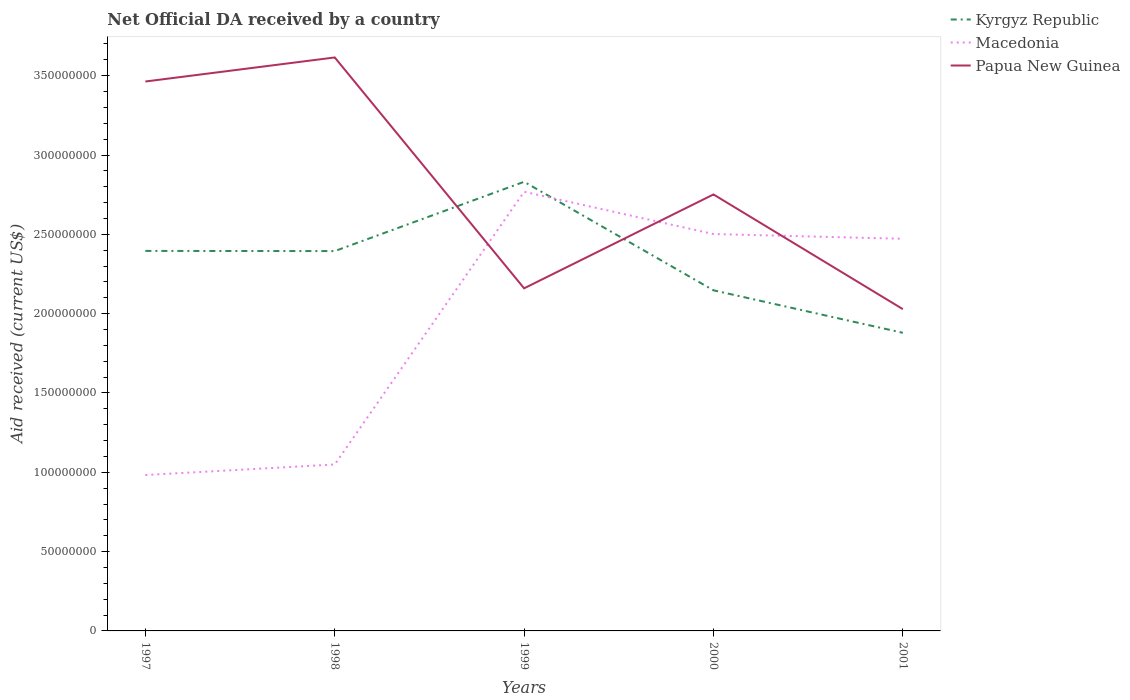How many different coloured lines are there?
Offer a very short reply. 3. Does the line corresponding to Papua New Guinea intersect with the line corresponding to Kyrgyz Republic?
Provide a succinct answer. Yes. Across all years, what is the maximum net official development assistance aid received in Kyrgyz Republic?
Offer a terse response. 1.88e+08. In which year was the net official development assistance aid received in Papua New Guinea maximum?
Make the answer very short. 2001. What is the total net official development assistance aid received in Kyrgyz Republic in the graph?
Give a very brief answer. 6.84e+07. What is the difference between the highest and the second highest net official development assistance aid received in Papua New Guinea?
Ensure brevity in your answer.  1.59e+08. Is the net official development assistance aid received in Papua New Guinea strictly greater than the net official development assistance aid received in Kyrgyz Republic over the years?
Make the answer very short. No. How many lines are there?
Ensure brevity in your answer.  3. How are the legend labels stacked?
Your response must be concise. Vertical. What is the title of the graph?
Your response must be concise. Net Official DA received by a country. Does "Portugal" appear as one of the legend labels in the graph?
Your answer should be very brief. No. What is the label or title of the X-axis?
Offer a terse response. Years. What is the label or title of the Y-axis?
Ensure brevity in your answer.  Aid received (current US$). What is the Aid received (current US$) of Kyrgyz Republic in 1997?
Give a very brief answer. 2.40e+08. What is the Aid received (current US$) of Macedonia in 1997?
Keep it short and to the point. 9.83e+07. What is the Aid received (current US$) in Papua New Guinea in 1997?
Keep it short and to the point. 3.46e+08. What is the Aid received (current US$) in Kyrgyz Republic in 1998?
Give a very brief answer. 2.39e+08. What is the Aid received (current US$) of Macedonia in 1998?
Provide a short and direct response. 1.05e+08. What is the Aid received (current US$) of Papua New Guinea in 1998?
Offer a very short reply. 3.62e+08. What is the Aid received (current US$) of Kyrgyz Republic in 1999?
Make the answer very short. 2.83e+08. What is the Aid received (current US$) of Macedonia in 1999?
Provide a short and direct response. 2.77e+08. What is the Aid received (current US$) of Papua New Guinea in 1999?
Offer a very short reply. 2.16e+08. What is the Aid received (current US$) in Kyrgyz Republic in 2000?
Offer a terse response. 2.15e+08. What is the Aid received (current US$) of Macedonia in 2000?
Offer a very short reply. 2.50e+08. What is the Aid received (current US$) in Papua New Guinea in 2000?
Your answer should be very brief. 2.75e+08. What is the Aid received (current US$) in Kyrgyz Republic in 2001?
Provide a short and direct response. 1.88e+08. What is the Aid received (current US$) in Macedonia in 2001?
Provide a succinct answer. 2.47e+08. What is the Aid received (current US$) in Papua New Guinea in 2001?
Offer a terse response. 2.03e+08. Across all years, what is the maximum Aid received (current US$) of Kyrgyz Republic?
Your response must be concise. 2.83e+08. Across all years, what is the maximum Aid received (current US$) in Macedonia?
Your answer should be very brief. 2.77e+08. Across all years, what is the maximum Aid received (current US$) of Papua New Guinea?
Offer a very short reply. 3.62e+08. Across all years, what is the minimum Aid received (current US$) in Kyrgyz Republic?
Ensure brevity in your answer.  1.88e+08. Across all years, what is the minimum Aid received (current US$) of Macedonia?
Offer a very short reply. 9.83e+07. Across all years, what is the minimum Aid received (current US$) of Papua New Guinea?
Give a very brief answer. 2.03e+08. What is the total Aid received (current US$) of Kyrgyz Republic in the graph?
Offer a terse response. 1.16e+09. What is the total Aid received (current US$) of Macedonia in the graph?
Give a very brief answer. 9.77e+08. What is the total Aid received (current US$) of Papua New Guinea in the graph?
Your response must be concise. 1.40e+09. What is the difference between the Aid received (current US$) in Kyrgyz Republic in 1997 and that in 1998?
Your answer should be very brief. 1.00e+05. What is the difference between the Aid received (current US$) in Macedonia in 1997 and that in 1998?
Your answer should be compact. -6.63e+06. What is the difference between the Aid received (current US$) of Papua New Guinea in 1997 and that in 1998?
Ensure brevity in your answer.  -1.52e+07. What is the difference between the Aid received (current US$) in Kyrgyz Republic in 1997 and that in 1999?
Give a very brief answer. -4.36e+07. What is the difference between the Aid received (current US$) in Macedonia in 1997 and that in 1999?
Your answer should be very brief. -1.79e+08. What is the difference between the Aid received (current US$) in Papua New Guinea in 1997 and that in 1999?
Keep it short and to the point. 1.30e+08. What is the difference between the Aid received (current US$) in Kyrgyz Republic in 1997 and that in 2000?
Your answer should be compact. 2.48e+07. What is the difference between the Aid received (current US$) of Macedonia in 1997 and that in 2000?
Your answer should be very brief. -1.52e+08. What is the difference between the Aid received (current US$) in Papua New Guinea in 1997 and that in 2000?
Your response must be concise. 7.12e+07. What is the difference between the Aid received (current US$) of Kyrgyz Republic in 1997 and that in 2001?
Offer a very short reply. 5.16e+07. What is the difference between the Aid received (current US$) of Macedonia in 1997 and that in 2001?
Your response must be concise. -1.49e+08. What is the difference between the Aid received (current US$) of Papua New Guinea in 1997 and that in 2001?
Your answer should be very brief. 1.44e+08. What is the difference between the Aid received (current US$) of Kyrgyz Republic in 1998 and that in 1999?
Your response must be concise. -4.37e+07. What is the difference between the Aid received (current US$) in Macedonia in 1998 and that in 1999?
Make the answer very short. -1.72e+08. What is the difference between the Aid received (current US$) in Papua New Guinea in 1998 and that in 1999?
Make the answer very short. 1.46e+08. What is the difference between the Aid received (current US$) of Kyrgyz Republic in 1998 and that in 2000?
Your response must be concise. 2.47e+07. What is the difference between the Aid received (current US$) of Macedonia in 1998 and that in 2000?
Provide a short and direct response. -1.45e+08. What is the difference between the Aid received (current US$) in Papua New Guinea in 1998 and that in 2000?
Your response must be concise. 8.64e+07. What is the difference between the Aid received (current US$) in Kyrgyz Republic in 1998 and that in 2001?
Offer a very short reply. 5.15e+07. What is the difference between the Aid received (current US$) in Macedonia in 1998 and that in 2001?
Provide a succinct answer. -1.42e+08. What is the difference between the Aid received (current US$) in Papua New Guinea in 1998 and that in 2001?
Offer a very short reply. 1.59e+08. What is the difference between the Aid received (current US$) in Kyrgyz Republic in 1999 and that in 2000?
Offer a very short reply. 6.84e+07. What is the difference between the Aid received (current US$) in Macedonia in 1999 and that in 2000?
Offer a very short reply. 2.66e+07. What is the difference between the Aid received (current US$) of Papua New Guinea in 1999 and that in 2000?
Provide a succinct answer. -5.92e+07. What is the difference between the Aid received (current US$) in Kyrgyz Republic in 1999 and that in 2001?
Your answer should be compact. 9.52e+07. What is the difference between the Aid received (current US$) in Macedonia in 1999 and that in 2001?
Provide a succinct answer. 2.96e+07. What is the difference between the Aid received (current US$) of Papua New Guinea in 1999 and that in 2001?
Your answer should be very brief. 1.31e+07. What is the difference between the Aid received (current US$) of Kyrgyz Republic in 2000 and that in 2001?
Offer a very short reply. 2.68e+07. What is the difference between the Aid received (current US$) of Macedonia in 2000 and that in 2001?
Give a very brief answer. 2.99e+06. What is the difference between the Aid received (current US$) of Papua New Guinea in 2000 and that in 2001?
Offer a very short reply. 7.23e+07. What is the difference between the Aid received (current US$) of Kyrgyz Republic in 1997 and the Aid received (current US$) of Macedonia in 1998?
Your response must be concise. 1.35e+08. What is the difference between the Aid received (current US$) of Kyrgyz Republic in 1997 and the Aid received (current US$) of Papua New Guinea in 1998?
Make the answer very short. -1.22e+08. What is the difference between the Aid received (current US$) in Macedonia in 1997 and the Aid received (current US$) in Papua New Guinea in 1998?
Your response must be concise. -2.63e+08. What is the difference between the Aid received (current US$) of Kyrgyz Republic in 1997 and the Aid received (current US$) of Macedonia in 1999?
Give a very brief answer. -3.73e+07. What is the difference between the Aid received (current US$) in Kyrgyz Republic in 1997 and the Aid received (current US$) in Papua New Guinea in 1999?
Give a very brief answer. 2.36e+07. What is the difference between the Aid received (current US$) of Macedonia in 1997 and the Aid received (current US$) of Papua New Guinea in 1999?
Offer a terse response. -1.18e+08. What is the difference between the Aid received (current US$) in Kyrgyz Republic in 1997 and the Aid received (current US$) in Macedonia in 2000?
Offer a terse response. -1.06e+07. What is the difference between the Aid received (current US$) in Kyrgyz Republic in 1997 and the Aid received (current US$) in Papua New Guinea in 2000?
Provide a succinct answer. -3.56e+07. What is the difference between the Aid received (current US$) of Macedonia in 1997 and the Aid received (current US$) of Papua New Guinea in 2000?
Give a very brief answer. -1.77e+08. What is the difference between the Aid received (current US$) of Kyrgyz Republic in 1997 and the Aid received (current US$) of Macedonia in 2001?
Ensure brevity in your answer.  -7.65e+06. What is the difference between the Aid received (current US$) of Kyrgyz Republic in 1997 and the Aid received (current US$) of Papua New Guinea in 2001?
Offer a very short reply. 3.67e+07. What is the difference between the Aid received (current US$) of Macedonia in 1997 and the Aid received (current US$) of Papua New Guinea in 2001?
Ensure brevity in your answer.  -1.05e+08. What is the difference between the Aid received (current US$) in Kyrgyz Republic in 1998 and the Aid received (current US$) in Macedonia in 1999?
Your answer should be compact. -3.74e+07. What is the difference between the Aid received (current US$) of Kyrgyz Republic in 1998 and the Aid received (current US$) of Papua New Guinea in 1999?
Provide a succinct answer. 2.35e+07. What is the difference between the Aid received (current US$) of Macedonia in 1998 and the Aid received (current US$) of Papua New Guinea in 1999?
Provide a short and direct response. -1.11e+08. What is the difference between the Aid received (current US$) in Kyrgyz Republic in 1998 and the Aid received (current US$) in Macedonia in 2000?
Give a very brief answer. -1.07e+07. What is the difference between the Aid received (current US$) in Kyrgyz Republic in 1998 and the Aid received (current US$) in Papua New Guinea in 2000?
Provide a short and direct response. -3.57e+07. What is the difference between the Aid received (current US$) in Macedonia in 1998 and the Aid received (current US$) in Papua New Guinea in 2000?
Ensure brevity in your answer.  -1.70e+08. What is the difference between the Aid received (current US$) in Kyrgyz Republic in 1998 and the Aid received (current US$) in Macedonia in 2001?
Provide a succinct answer. -7.75e+06. What is the difference between the Aid received (current US$) in Kyrgyz Republic in 1998 and the Aid received (current US$) in Papua New Guinea in 2001?
Offer a very short reply. 3.66e+07. What is the difference between the Aid received (current US$) in Macedonia in 1998 and the Aid received (current US$) in Papua New Guinea in 2001?
Your answer should be very brief. -9.79e+07. What is the difference between the Aid received (current US$) in Kyrgyz Republic in 1999 and the Aid received (current US$) in Macedonia in 2000?
Provide a short and direct response. 3.29e+07. What is the difference between the Aid received (current US$) of Kyrgyz Republic in 1999 and the Aid received (current US$) of Papua New Guinea in 2000?
Provide a short and direct response. 7.98e+06. What is the difference between the Aid received (current US$) in Macedonia in 1999 and the Aid received (current US$) in Papua New Guinea in 2000?
Offer a terse response. 1.68e+06. What is the difference between the Aid received (current US$) of Kyrgyz Republic in 1999 and the Aid received (current US$) of Macedonia in 2001?
Make the answer very short. 3.59e+07. What is the difference between the Aid received (current US$) of Kyrgyz Republic in 1999 and the Aid received (current US$) of Papua New Guinea in 2001?
Your answer should be very brief. 8.03e+07. What is the difference between the Aid received (current US$) of Macedonia in 1999 and the Aid received (current US$) of Papua New Guinea in 2001?
Keep it short and to the point. 7.40e+07. What is the difference between the Aid received (current US$) in Kyrgyz Republic in 2000 and the Aid received (current US$) in Macedonia in 2001?
Offer a terse response. -3.25e+07. What is the difference between the Aid received (current US$) of Kyrgyz Republic in 2000 and the Aid received (current US$) of Papua New Guinea in 2001?
Keep it short and to the point. 1.19e+07. What is the difference between the Aid received (current US$) in Macedonia in 2000 and the Aid received (current US$) in Papua New Guinea in 2001?
Offer a very short reply. 4.73e+07. What is the average Aid received (current US$) in Kyrgyz Republic per year?
Keep it short and to the point. 2.33e+08. What is the average Aid received (current US$) in Macedonia per year?
Give a very brief answer. 1.95e+08. What is the average Aid received (current US$) in Papua New Guinea per year?
Your answer should be compact. 2.80e+08. In the year 1997, what is the difference between the Aid received (current US$) of Kyrgyz Republic and Aid received (current US$) of Macedonia?
Provide a succinct answer. 1.41e+08. In the year 1997, what is the difference between the Aid received (current US$) in Kyrgyz Republic and Aid received (current US$) in Papua New Guinea?
Provide a short and direct response. -1.07e+08. In the year 1997, what is the difference between the Aid received (current US$) in Macedonia and Aid received (current US$) in Papua New Guinea?
Offer a terse response. -2.48e+08. In the year 1998, what is the difference between the Aid received (current US$) of Kyrgyz Republic and Aid received (current US$) of Macedonia?
Offer a terse response. 1.35e+08. In the year 1998, what is the difference between the Aid received (current US$) of Kyrgyz Republic and Aid received (current US$) of Papua New Guinea?
Give a very brief answer. -1.22e+08. In the year 1998, what is the difference between the Aid received (current US$) in Macedonia and Aid received (current US$) in Papua New Guinea?
Give a very brief answer. -2.57e+08. In the year 1999, what is the difference between the Aid received (current US$) in Kyrgyz Republic and Aid received (current US$) in Macedonia?
Make the answer very short. 6.30e+06. In the year 1999, what is the difference between the Aid received (current US$) of Kyrgyz Republic and Aid received (current US$) of Papua New Guinea?
Make the answer very short. 6.72e+07. In the year 1999, what is the difference between the Aid received (current US$) of Macedonia and Aid received (current US$) of Papua New Guinea?
Keep it short and to the point. 6.09e+07. In the year 2000, what is the difference between the Aid received (current US$) of Kyrgyz Republic and Aid received (current US$) of Macedonia?
Offer a terse response. -3.55e+07. In the year 2000, what is the difference between the Aid received (current US$) of Kyrgyz Republic and Aid received (current US$) of Papua New Guinea?
Provide a short and direct response. -6.04e+07. In the year 2000, what is the difference between the Aid received (current US$) of Macedonia and Aid received (current US$) of Papua New Guinea?
Ensure brevity in your answer.  -2.50e+07. In the year 2001, what is the difference between the Aid received (current US$) in Kyrgyz Republic and Aid received (current US$) in Macedonia?
Ensure brevity in your answer.  -5.93e+07. In the year 2001, what is the difference between the Aid received (current US$) in Kyrgyz Republic and Aid received (current US$) in Papua New Guinea?
Keep it short and to the point. -1.49e+07. In the year 2001, what is the difference between the Aid received (current US$) of Macedonia and Aid received (current US$) of Papua New Guinea?
Give a very brief answer. 4.44e+07. What is the ratio of the Aid received (current US$) of Kyrgyz Republic in 1997 to that in 1998?
Your answer should be compact. 1. What is the ratio of the Aid received (current US$) in Macedonia in 1997 to that in 1998?
Provide a succinct answer. 0.94. What is the ratio of the Aid received (current US$) in Papua New Guinea in 1997 to that in 1998?
Offer a terse response. 0.96. What is the ratio of the Aid received (current US$) of Kyrgyz Republic in 1997 to that in 1999?
Keep it short and to the point. 0.85. What is the ratio of the Aid received (current US$) of Macedonia in 1997 to that in 1999?
Offer a terse response. 0.35. What is the ratio of the Aid received (current US$) of Papua New Guinea in 1997 to that in 1999?
Offer a very short reply. 1.6. What is the ratio of the Aid received (current US$) in Kyrgyz Republic in 1997 to that in 2000?
Your answer should be very brief. 1.12. What is the ratio of the Aid received (current US$) of Macedonia in 1997 to that in 2000?
Offer a very short reply. 0.39. What is the ratio of the Aid received (current US$) of Papua New Guinea in 1997 to that in 2000?
Give a very brief answer. 1.26. What is the ratio of the Aid received (current US$) of Kyrgyz Republic in 1997 to that in 2001?
Offer a terse response. 1.27. What is the ratio of the Aid received (current US$) of Macedonia in 1997 to that in 2001?
Your response must be concise. 0.4. What is the ratio of the Aid received (current US$) of Papua New Guinea in 1997 to that in 2001?
Your answer should be compact. 1.71. What is the ratio of the Aid received (current US$) of Kyrgyz Republic in 1998 to that in 1999?
Your answer should be very brief. 0.85. What is the ratio of the Aid received (current US$) in Macedonia in 1998 to that in 1999?
Offer a terse response. 0.38. What is the ratio of the Aid received (current US$) in Papua New Guinea in 1998 to that in 1999?
Give a very brief answer. 1.67. What is the ratio of the Aid received (current US$) in Kyrgyz Republic in 1998 to that in 2000?
Provide a succinct answer. 1.12. What is the ratio of the Aid received (current US$) of Macedonia in 1998 to that in 2000?
Your answer should be compact. 0.42. What is the ratio of the Aid received (current US$) in Papua New Guinea in 1998 to that in 2000?
Give a very brief answer. 1.31. What is the ratio of the Aid received (current US$) in Kyrgyz Republic in 1998 to that in 2001?
Keep it short and to the point. 1.27. What is the ratio of the Aid received (current US$) in Macedonia in 1998 to that in 2001?
Provide a succinct answer. 0.42. What is the ratio of the Aid received (current US$) in Papua New Guinea in 1998 to that in 2001?
Make the answer very short. 1.78. What is the ratio of the Aid received (current US$) of Kyrgyz Republic in 1999 to that in 2000?
Offer a terse response. 1.32. What is the ratio of the Aid received (current US$) in Macedonia in 1999 to that in 2000?
Ensure brevity in your answer.  1.11. What is the ratio of the Aid received (current US$) of Papua New Guinea in 1999 to that in 2000?
Provide a short and direct response. 0.78. What is the ratio of the Aid received (current US$) of Kyrgyz Republic in 1999 to that in 2001?
Give a very brief answer. 1.51. What is the ratio of the Aid received (current US$) in Macedonia in 1999 to that in 2001?
Give a very brief answer. 1.12. What is the ratio of the Aid received (current US$) of Papua New Guinea in 1999 to that in 2001?
Offer a very short reply. 1.06. What is the ratio of the Aid received (current US$) in Kyrgyz Republic in 2000 to that in 2001?
Your response must be concise. 1.14. What is the ratio of the Aid received (current US$) of Macedonia in 2000 to that in 2001?
Your answer should be very brief. 1.01. What is the ratio of the Aid received (current US$) of Papua New Guinea in 2000 to that in 2001?
Offer a terse response. 1.36. What is the difference between the highest and the second highest Aid received (current US$) in Kyrgyz Republic?
Make the answer very short. 4.36e+07. What is the difference between the highest and the second highest Aid received (current US$) of Macedonia?
Ensure brevity in your answer.  2.66e+07. What is the difference between the highest and the second highest Aid received (current US$) of Papua New Guinea?
Offer a terse response. 1.52e+07. What is the difference between the highest and the lowest Aid received (current US$) of Kyrgyz Republic?
Offer a very short reply. 9.52e+07. What is the difference between the highest and the lowest Aid received (current US$) of Macedonia?
Make the answer very short. 1.79e+08. What is the difference between the highest and the lowest Aid received (current US$) of Papua New Guinea?
Your answer should be very brief. 1.59e+08. 